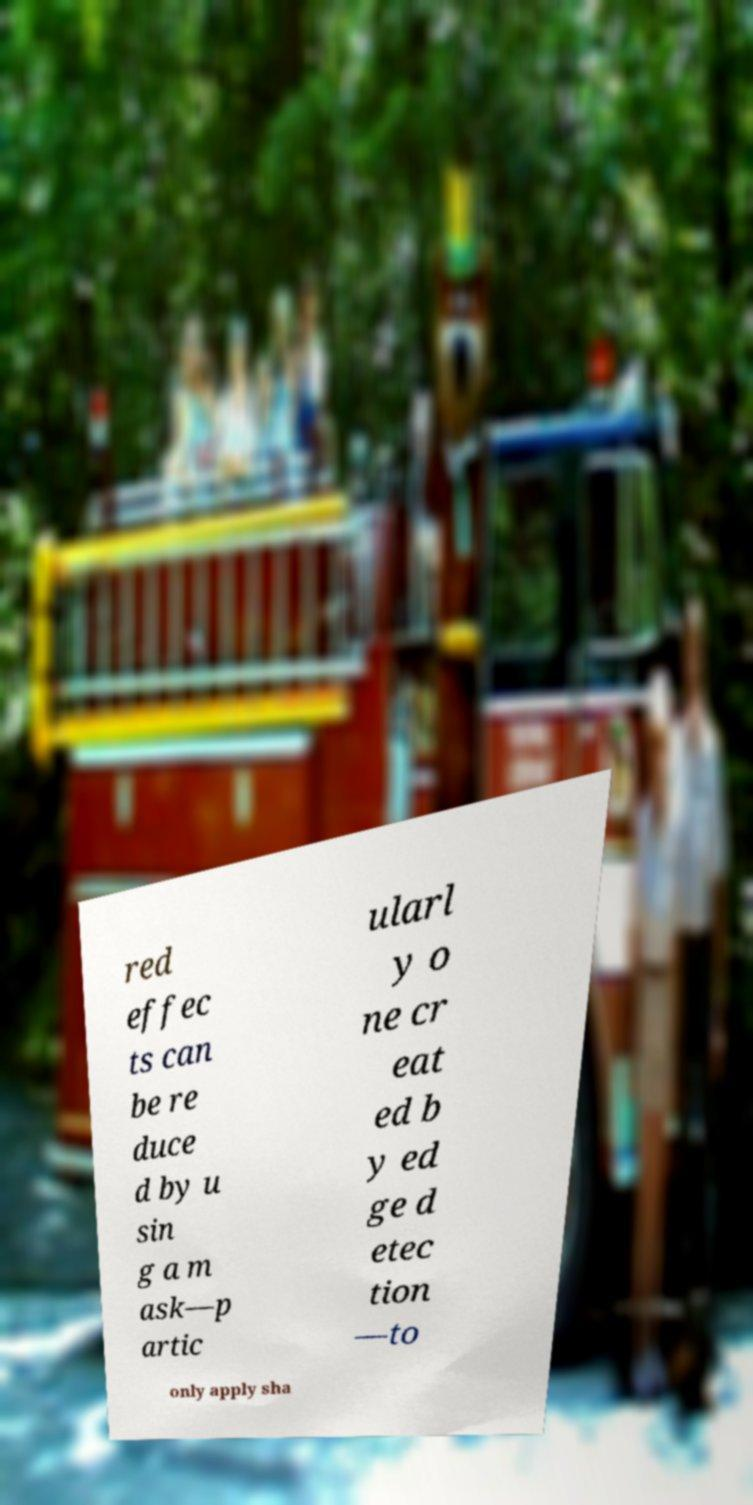Please read and relay the text visible in this image. What does it say? red effec ts can be re duce d by u sin g a m ask—p artic ularl y o ne cr eat ed b y ed ge d etec tion —to only apply sha 